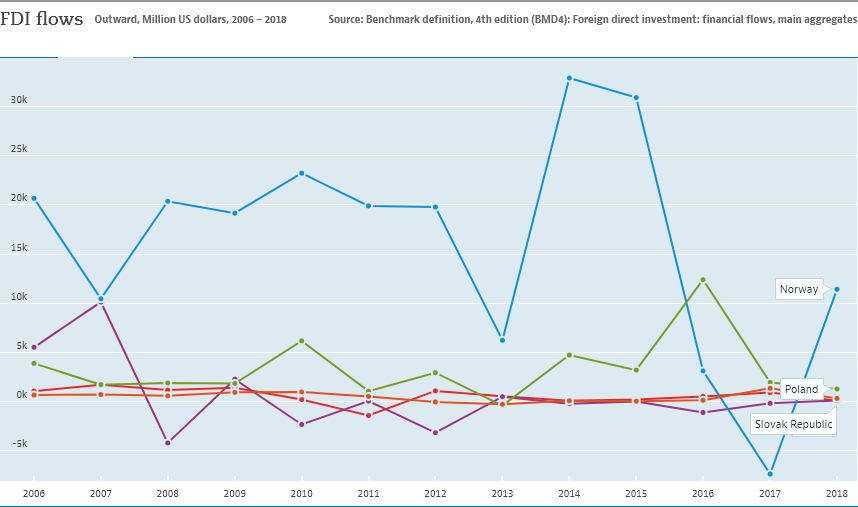Highlight a few significant elements in this photo. This graph represents the participation of 3 countries/regions. In 2014, Norway experienced the greatest increase in electric vehicle adoption compared to any other year. 